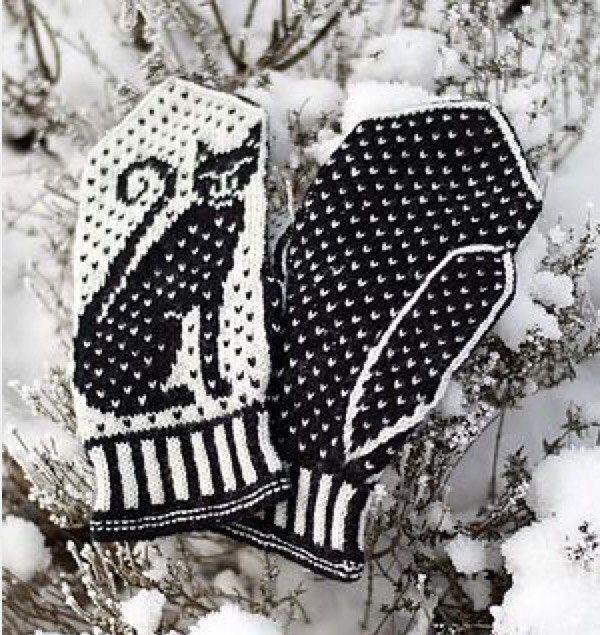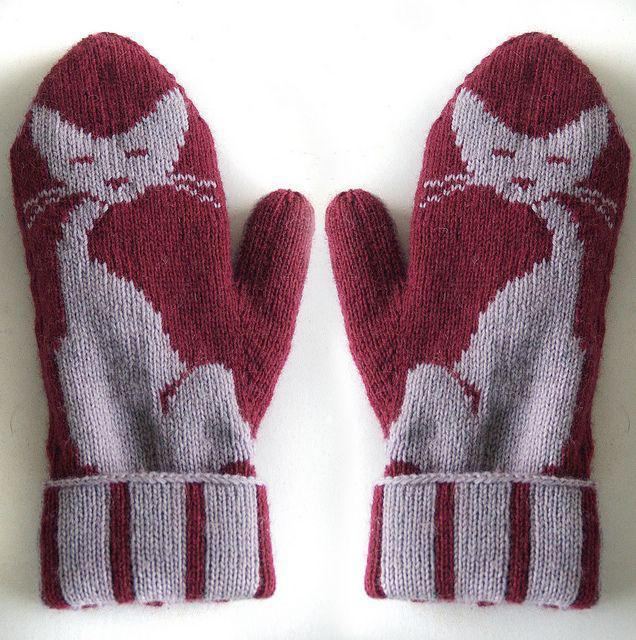The first image is the image on the left, the second image is the image on the right. Examine the images to the left and right. Is the description "In 1 of the images, 2 gloves have thumbs pointing inward." accurate? Answer yes or no. Yes. The first image is the image on the left, the second image is the image on the right. Examine the images to the left and right. Is the description "The items in the right image is laid on a plain white surface." accurate? Answer yes or no. Yes. 